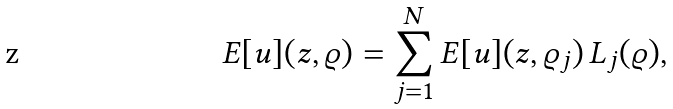<formula> <loc_0><loc_0><loc_500><loc_500>E [ u ] ( z , \varrho ) = \sum _ { j = 1 } ^ { N } E [ u ] ( z , \varrho _ { j } ) \, L _ { j } ( \varrho ) ,</formula> 